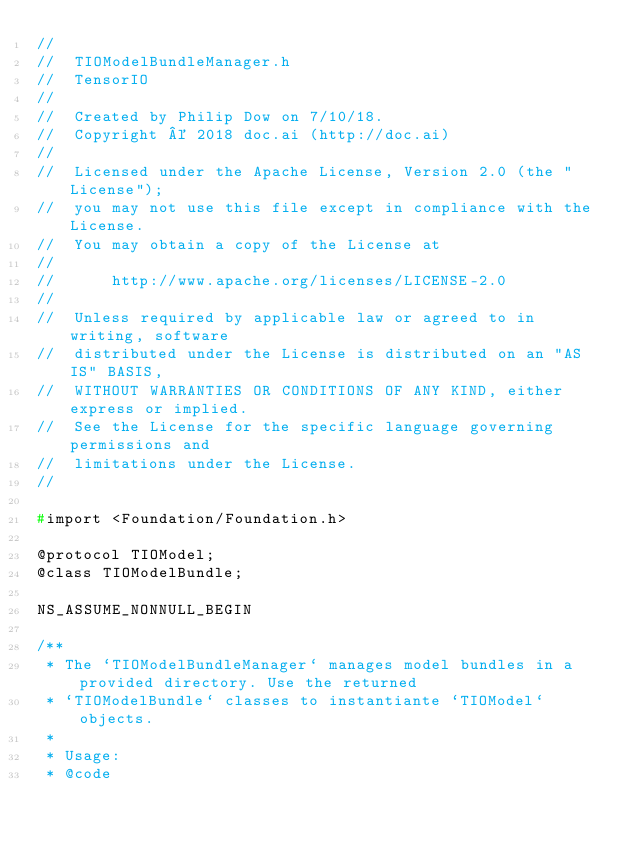<code> <loc_0><loc_0><loc_500><loc_500><_C_>//
//  TIOModelBundleManager.h
//  TensorIO
//
//  Created by Philip Dow on 7/10/18.
//  Copyright © 2018 doc.ai (http://doc.ai)
//
//  Licensed under the Apache License, Version 2.0 (the "License");
//  you may not use this file except in compliance with the License.
//  You may obtain a copy of the License at
//
//      http://www.apache.org/licenses/LICENSE-2.0
//
//  Unless required by applicable law or agreed to in writing, software
//  distributed under the License is distributed on an "AS IS" BASIS,
//  WITHOUT WARRANTIES OR CONDITIONS OF ANY KIND, either express or implied.
//  See the License for the specific language governing permissions and
//  limitations under the License.
//

#import <Foundation/Foundation.h>

@protocol TIOModel;
@class TIOModelBundle;

NS_ASSUME_NONNULL_BEGIN

/**
 * The `TIOModelBundleManager` manages model bundles in a provided directory. Use the returned
 * `TIOModelBundle` classes to instantiante `TIOModel` objects.
 *
 * Usage:
 * @code</code> 